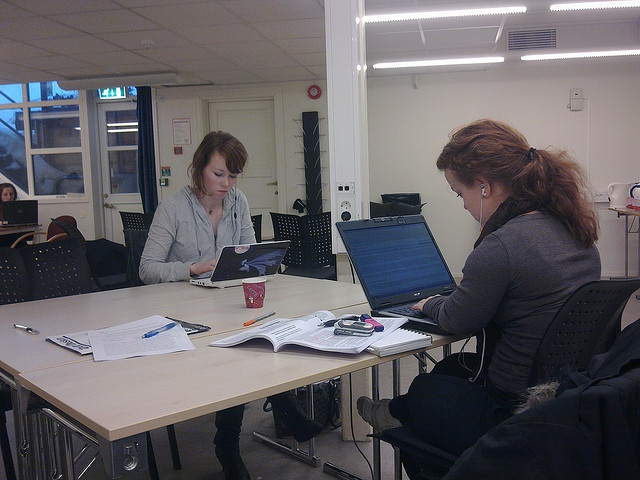Describe the objects in this image and their specific colors. I can see people in gray and black tones, people in gray and black tones, chair in gray and black tones, laptop in gray, darkblue, navy, and black tones, and book in gray, lavender, darkgray, and lightgray tones in this image. 